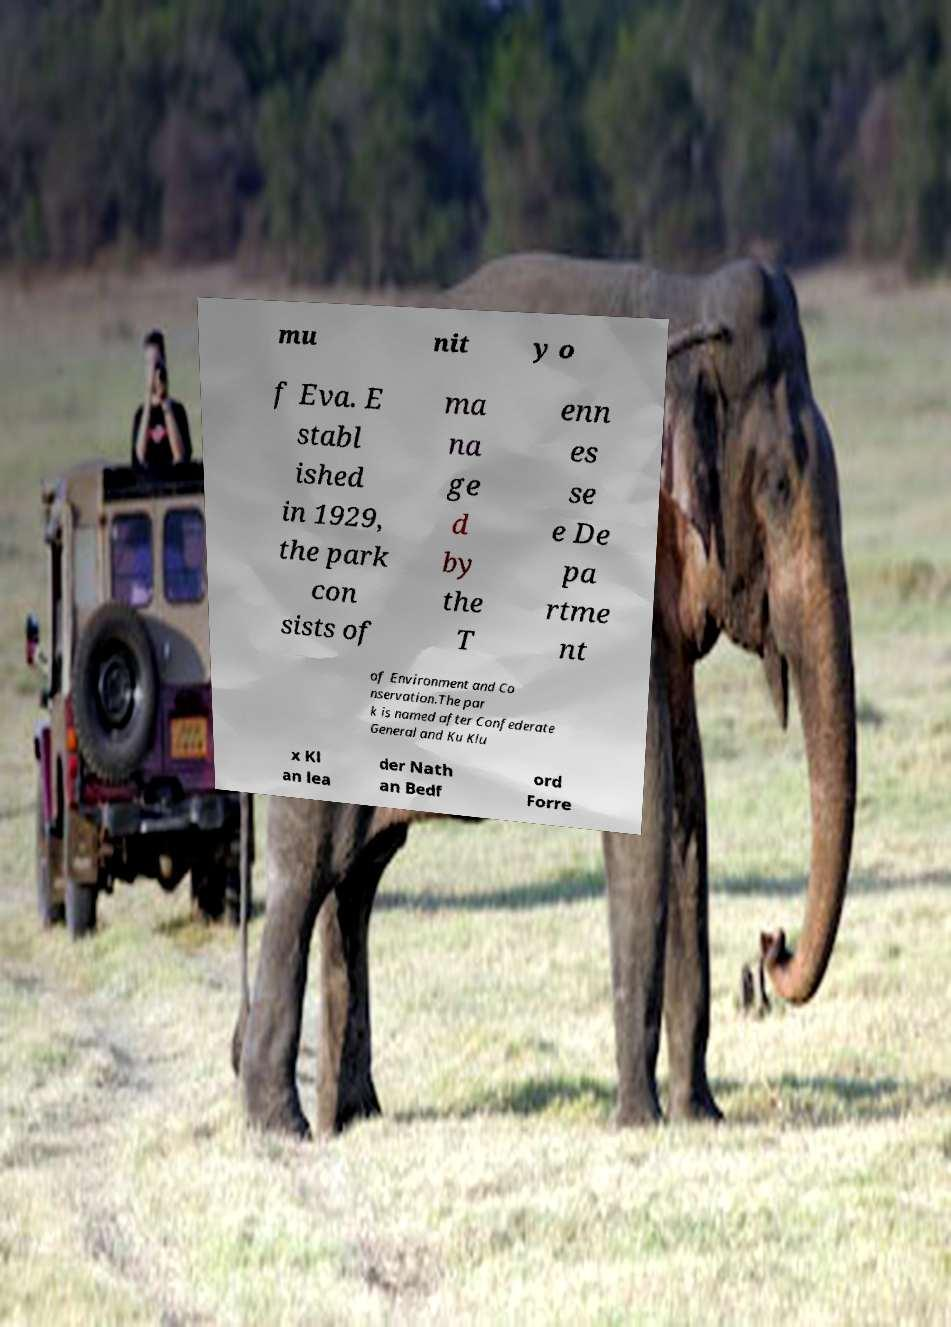What messages or text are displayed in this image? I need them in a readable, typed format. mu nit y o f Eva. E stabl ished in 1929, the park con sists of ma na ge d by the T enn es se e De pa rtme nt of Environment and Co nservation.The par k is named after Confederate General and Ku Klu x Kl an lea der Nath an Bedf ord Forre 